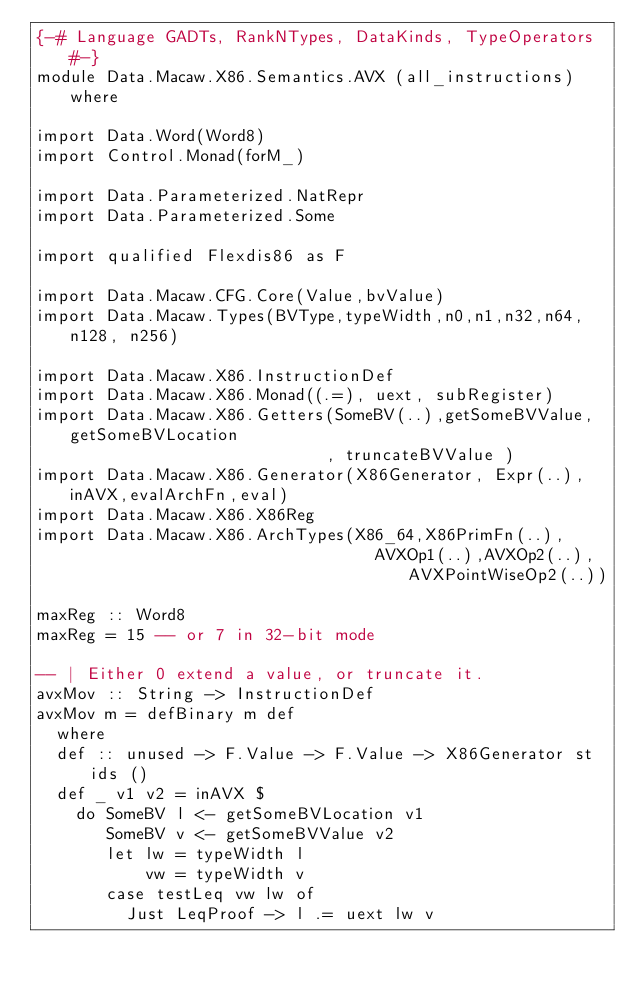<code> <loc_0><loc_0><loc_500><loc_500><_Haskell_>{-# Language GADTs, RankNTypes, DataKinds, TypeOperators #-}
module Data.Macaw.X86.Semantics.AVX (all_instructions) where

import Data.Word(Word8)
import Control.Monad(forM_)

import Data.Parameterized.NatRepr
import Data.Parameterized.Some

import qualified Flexdis86 as F

import Data.Macaw.CFG.Core(Value,bvValue)
import Data.Macaw.Types(BVType,typeWidth,n0,n1,n32,n64,n128, n256)

import Data.Macaw.X86.InstructionDef
import Data.Macaw.X86.Monad((.=), uext, subRegister)
import Data.Macaw.X86.Getters(SomeBV(..),getSomeBVValue,getSomeBVLocation
                             , truncateBVValue )
import Data.Macaw.X86.Generator(X86Generator, Expr(..),inAVX,evalArchFn,eval)
import Data.Macaw.X86.X86Reg
import Data.Macaw.X86.ArchTypes(X86_64,X86PrimFn(..),
                                  AVXOp1(..),AVXOp2(..),AVXPointWiseOp2(..))

maxReg :: Word8
maxReg = 15 -- or 7 in 32-bit mode

-- | Either 0 extend a value, or truncate it.
avxMov :: String -> InstructionDef
avxMov m = defBinary m def
  where
  def :: unused -> F.Value -> F.Value -> X86Generator st ids ()
  def _ v1 v2 = inAVX $
    do SomeBV l <- getSomeBVLocation v1
       SomeBV v <- getSomeBVValue v2
       let lw = typeWidth l
           vw = typeWidth v
       case testLeq vw lw of
         Just LeqProof -> l .= uext lw v</code> 